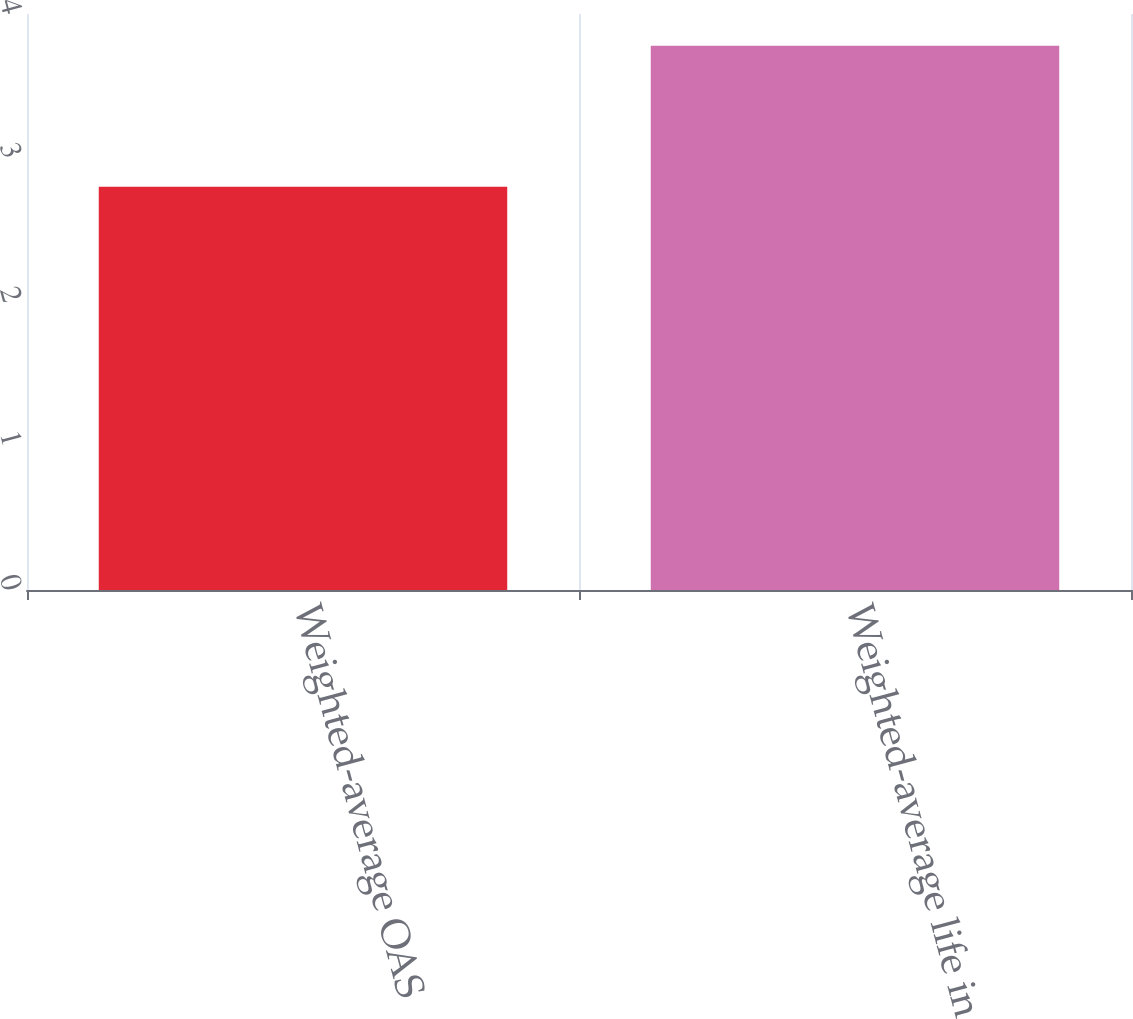Convert chart. <chart><loc_0><loc_0><loc_500><loc_500><bar_chart><fcel>Weighted-average OAS<fcel>Weighted-average life in years<nl><fcel>2.8<fcel>3.78<nl></chart> 